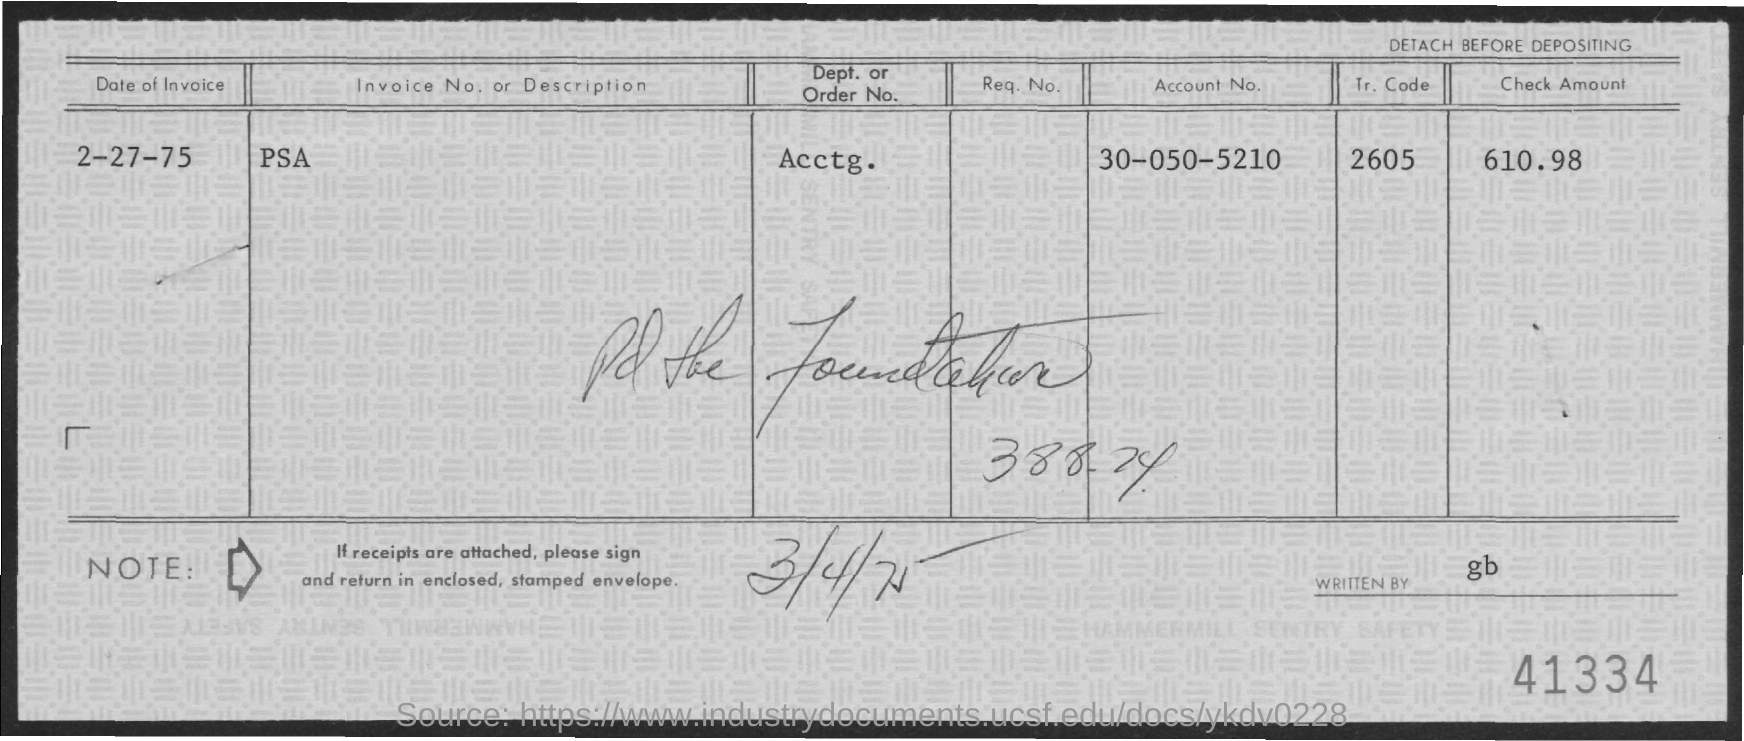What is the Account Number ?
Your answer should be compact. 30-050-5210. What is the Dept. or Order No. ?
Offer a terse response. Acctg. How much Check amount ?
Offer a very short reply. 610.98. Who is written this ?
Offer a terse response. Gb. What is the Tr. Code
Your response must be concise. 2605. 